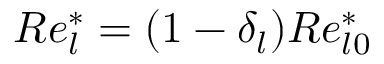<formula> <loc_0><loc_0><loc_500><loc_500>R e _ { l } ^ { * } = ( 1 - \delta _ { l } ) R e _ { l 0 } ^ { * }</formula> 